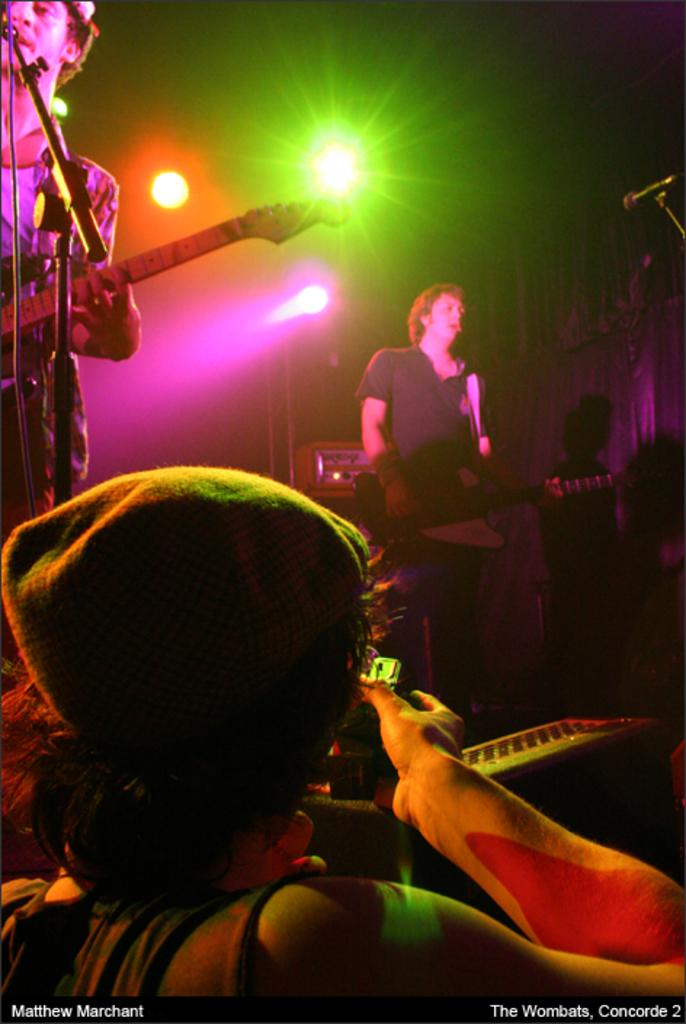How many people are in the image? There are two persons in the image. What is one of the persons doing in the image? One of the persons is singing and playing the guitar. Can you describe any additional features in the image? Disco lights are attached to the ceiling. What type of snakes can be seen slithering on the floor in the image? There are no snakes present in the image. What is the zinc content of the guitar in the image? The image does not provide information about the guitar's zinc content. 